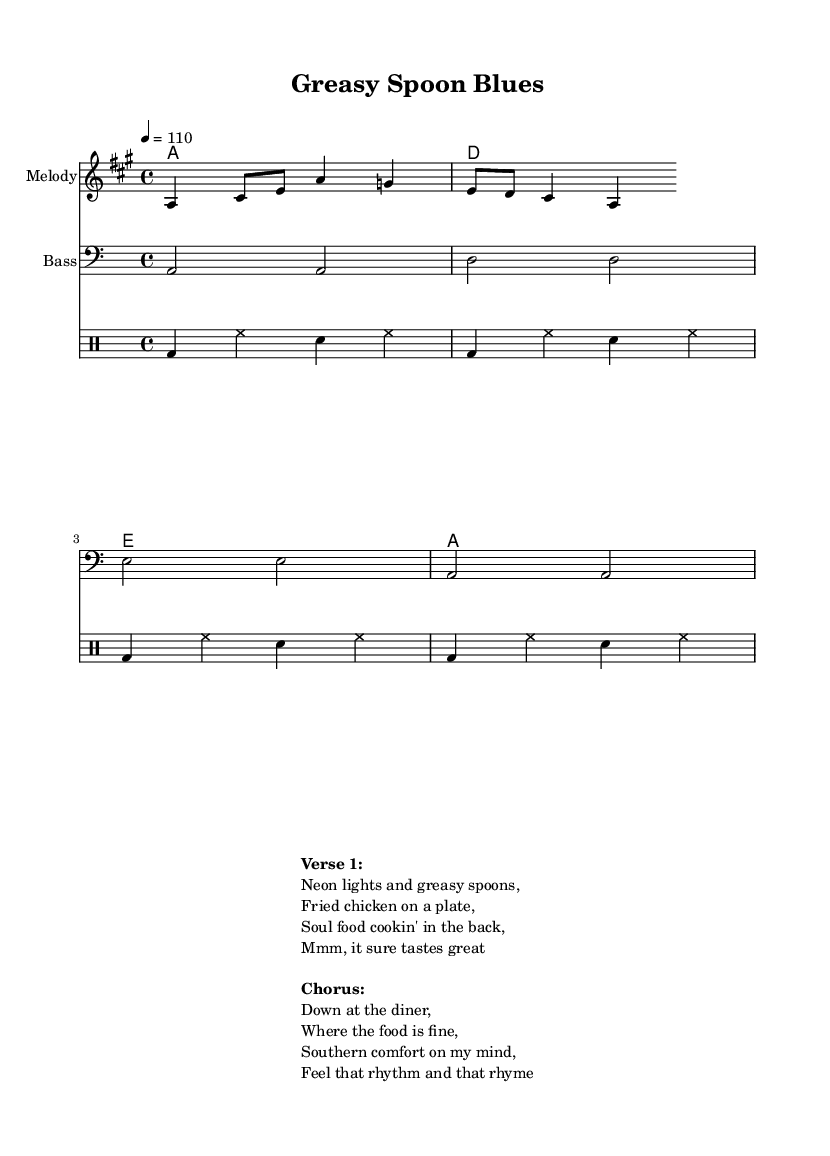What is the key signature of this music? The key signature is A major, which contains three sharps (F#, C#, and G#). This is identified by looking at the key indication at the beginning of the score.
Answer: A major What is the time signature of this music? The time signature is 4/4, indicating four beats per measure with each quarter note receiving one beat. This can be seen in the notation right after the key signature at the start of the piece.
Answer: 4/4 What is the tempo marking of this piece? The tempo marking indicates a speed of 110 beats per minute, as noted in the score under the tempo indication. This guides musicians on how fast to play the piece.
Answer: 110 What is the primary mood or theme of the lyrics? The lyrics convey a mood centered around comfort and indulgence, focusing on soul food and a diner atmosphere. This can be deducted from phrases like "Fried chicken on a plate" and "Southern comfort on my mind" found in the lyrics section.
Answer: Comfort What chords are used in the harmony section? The chords used in the harmony section are A, D, and E, which are expressed through the chord notation at the beginning of the score. These chords are standard in Southern rock and contribute to the overall feel of the piece.
Answer: A, D, E How many measures are in the melody? The melody consists of 4 measures, as can be counted from the notation provided in the melody section. Each measure is defined by the vertical bar lines in the score.
Answer: 4 What is the style of the music piece? The style of the piece can be categorized as Southern rock, characterized by its blend of rock with elements of blues and country, reflected in the lyrical content and musical structure. The thematic focus on diners and soul food further emphasizes this style.
Answer: Southern rock 